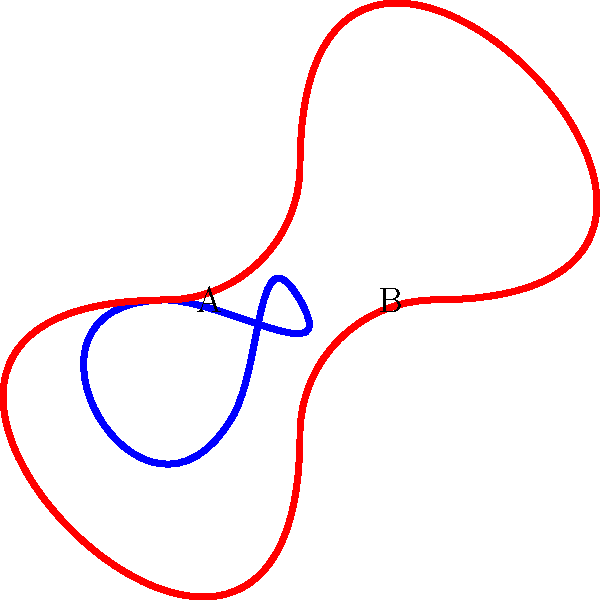As a proud grandparent of Brittni Emonds, you've been teaching her about different types of knots. Look at the two knots shown in the diagram. Knot A (blue) is a trefoil knot, and Knot B (red) is a figure-eight knot. Which of these knots has a higher crossing number, and what does this imply about its complexity? To answer this question, we need to understand the concept of crossing numbers and how they relate to knot complexity:

1. Crossing number: The minimum number of crossings that occur in any projection of a knot onto a plane.

2. Trefoil knot (Knot A):
   - Has a crossing number of 3
   - It's the simplest non-trivial knot

3. Figure-eight knot (Knot B):
   - Has a crossing number of 4
   - It's more complex than the trefoil knot

4. Relationship between crossing number and complexity:
   - Higher crossing number generally indicates greater complexity
   - More crossings mean the knot is more difficult to untangle or classify

5. Comparison:
   - Figure-eight knot (4 crossings) > Trefoil knot (3 crossings)

Therefore, the figure-eight knot (Knot B) has a higher crossing number, implying it is more complex than the trefoil knot (Knot A).
Answer: Figure-eight knot (B); higher complexity 